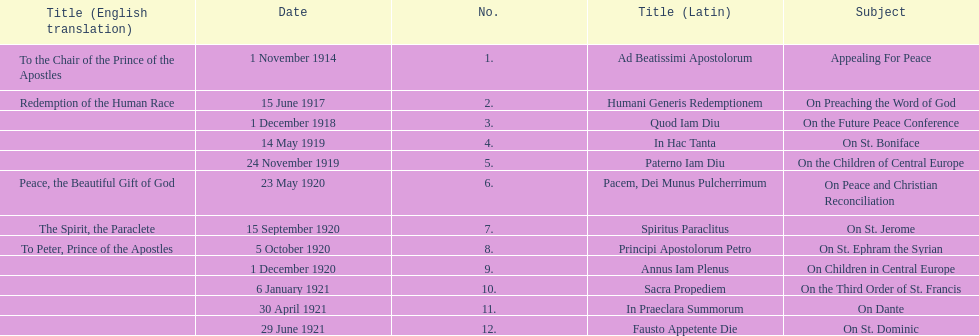Other than january how many encyclicals were in 1921? 2. 